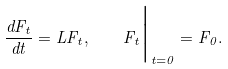<formula> <loc_0><loc_0><loc_500><loc_500>\frac { d F _ { t } } { d t } = L F _ { t } , \quad F _ { t } \Big | _ { t = 0 } = F _ { 0 } .</formula> 